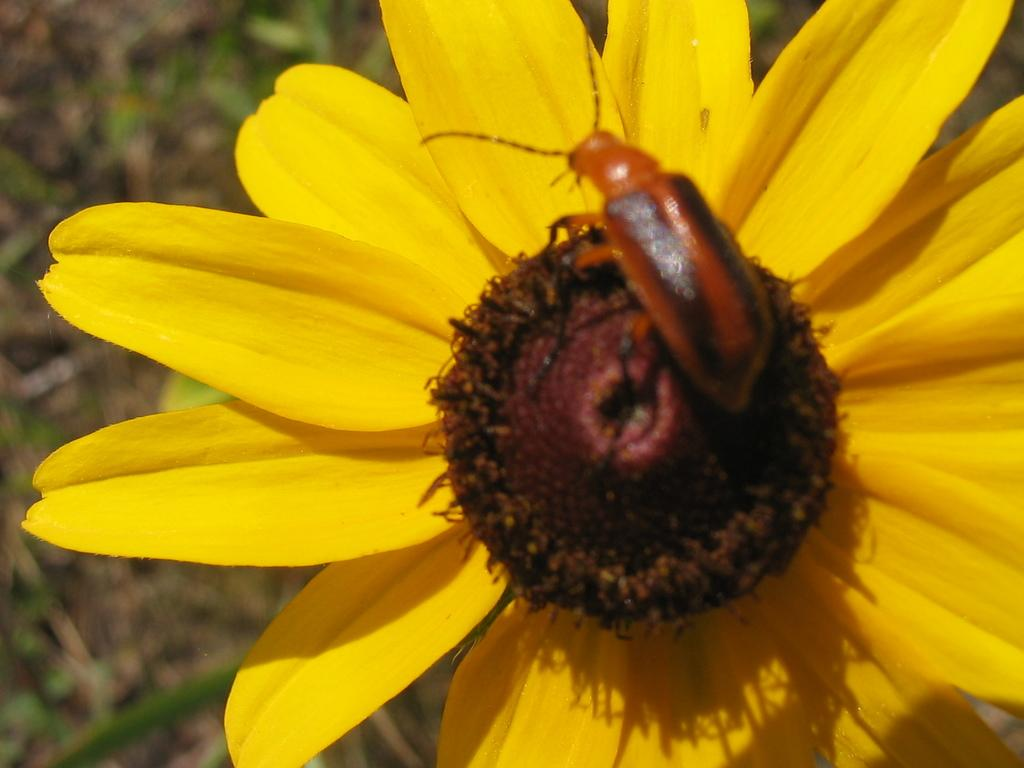What is the main subject of the image? There is an insect on a flower in the image. Can you describe the background of the image? The background of the image is blurred. What type of celery can be seen in the background of the image? There is no celery present in the image. Can you tell me how many credits the insect has earned in the image? There is no reference to credits or any form of currency in the image. 